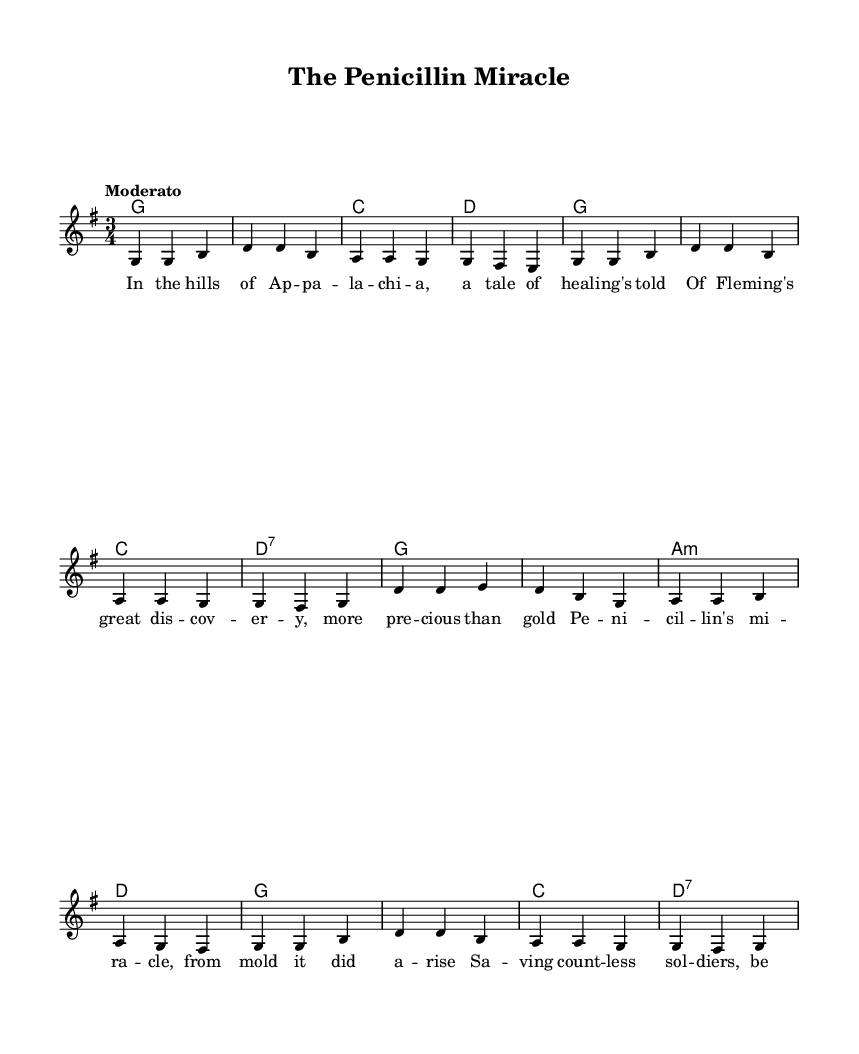What is the key signature of this music? The key signature is G major, which contains one sharp (F#). This can be determined by looking at the key signature notated at the beginning of the sheet music.
Answer: G major What is the time signature of the piece? The time signature is 3/4, which is indicated at the beginning of the score. This means there are three beats in each measure, and each quarter note gets one beat.
Answer: 3/4 What is the tempo marking for the piece? The tempo marking is "Moderato," suggesting a moderate pace for the performance. This is provided in the tempo indication at the beginning of the score.
Answer: Moderato How many measures are there in the melody? The melody consists of 12 measures, which can be counted by observing the bar lines separating the measures in the staff.
Answer: 12 What is the first lyric line of the verse? The first lyric line is "In the hills of Ap -- pa -- la -- chi -- a," which can be found directly under the melody staff, aligned with the corresponding notes.
Answer: In the hills of Ap -- pa -- la -- chi -- a What chord follows the G chord in the harmonies section? The chord that follows the G chord in the harmonies is C, as seen in the chord progression notated below the melody. The first few chords in sequence confirm this order.
Answer: C What medical discovery is referenced in the ballad? The ballad references "Fleming's great discovery," which is noted as significant in the lyrics related to medical breakthroughs. This information can be found in the lyrics of the song.
Answer: Fleming's great discovery 